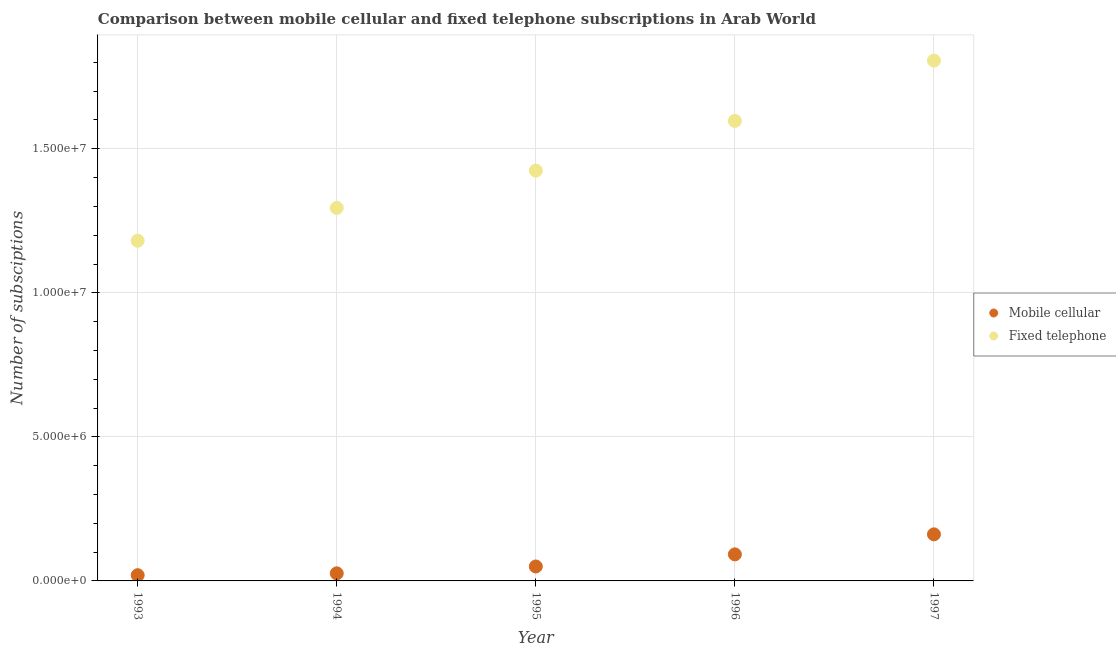What is the number of mobile cellular subscriptions in 1996?
Ensure brevity in your answer.  9.21e+05. Across all years, what is the maximum number of mobile cellular subscriptions?
Keep it short and to the point. 1.62e+06. Across all years, what is the minimum number of mobile cellular subscriptions?
Ensure brevity in your answer.  1.99e+05. In which year was the number of mobile cellular subscriptions maximum?
Give a very brief answer. 1997. What is the total number of fixed telephone subscriptions in the graph?
Provide a short and direct response. 7.30e+07. What is the difference between the number of fixed telephone subscriptions in 1993 and that in 1995?
Give a very brief answer. -2.43e+06. What is the difference between the number of fixed telephone subscriptions in 1994 and the number of mobile cellular subscriptions in 1996?
Offer a terse response. 1.20e+07. What is the average number of mobile cellular subscriptions per year?
Your answer should be very brief. 7.00e+05. In the year 1995, what is the difference between the number of fixed telephone subscriptions and number of mobile cellular subscriptions?
Ensure brevity in your answer.  1.37e+07. What is the ratio of the number of mobile cellular subscriptions in 1995 to that in 1997?
Provide a short and direct response. 0.31. Is the number of mobile cellular subscriptions in 1994 less than that in 1997?
Ensure brevity in your answer.  Yes. Is the difference between the number of mobile cellular subscriptions in 1994 and 1995 greater than the difference between the number of fixed telephone subscriptions in 1994 and 1995?
Keep it short and to the point. Yes. What is the difference between the highest and the second highest number of fixed telephone subscriptions?
Your response must be concise. 2.09e+06. What is the difference between the highest and the lowest number of fixed telephone subscriptions?
Ensure brevity in your answer.  6.25e+06. Does the number of fixed telephone subscriptions monotonically increase over the years?
Offer a very short reply. Yes. Is the number of mobile cellular subscriptions strictly less than the number of fixed telephone subscriptions over the years?
Your answer should be compact. Yes. Are the values on the major ticks of Y-axis written in scientific E-notation?
Make the answer very short. Yes. Where does the legend appear in the graph?
Keep it short and to the point. Center right. How many legend labels are there?
Ensure brevity in your answer.  2. How are the legend labels stacked?
Provide a succinct answer. Vertical. What is the title of the graph?
Your response must be concise. Comparison between mobile cellular and fixed telephone subscriptions in Arab World. Does "Residents" appear as one of the legend labels in the graph?
Provide a succinct answer. No. What is the label or title of the Y-axis?
Provide a succinct answer. Number of subsciptions. What is the Number of subsciptions of Mobile cellular in 1993?
Offer a terse response. 1.99e+05. What is the Number of subsciptions in Fixed telephone in 1993?
Keep it short and to the point. 1.18e+07. What is the Number of subsciptions in Mobile cellular in 1994?
Your answer should be compact. 2.63e+05. What is the Number of subsciptions in Fixed telephone in 1994?
Your answer should be compact. 1.29e+07. What is the Number of subsciptions in Mobile cellular in 1995?
Your answer should be compact. 5.02e+05. What is the Number of subsciptions of Fixed telephone in 1995?
Ensure brevity in your answer.  1.42e+07. What is the Number of subsciptions in Mobile cellular in 1996?
Provide a short and direct response. 9.21e+05. What is the Number of subsciptions of Fixed telephone in 1996?
Keep it short and to the point. 1.60e+07. What is the Number of subsciptions in Mobile cellular in 1997?
Your answer should be compact. 1.62e+06. What is the Number of subsciptions in Fixed telephone in 1997?
Your response must be concise. 1.81e+07. Across all years, what is the maximum Number of subsciptions of Mobile cellular?
Provide a short and direct response. 1.62e+06. Across all years, what is the maximum Number of subsciptions of Fixed telephone?
Ensure brevity in your answer.  1.81e+07. Across all years, what is the minimum Number of subsciptions in Mobile cellular?
Keep it short and to the point. 1.99e+05. Across all years, what is the minimum Number of subsciptions of Fixed telephone?
Ensure brevity in your answer.  1.18e+07. What is the total Number of subsciptions of Mobile cellular in the graph?
Provide a succinct answer. 3.50e+06. What is the total Number of subsciptions in Fixed telephone in the graph?
Your answer should be very brief. 7.30e+07. What is the difference between the Number of subsciptions of Mobile cellular in 1993 and that in 1994?
Keep it short and to the point. -6.41e+04. What is the difference between the Number of subsciptions of Fixed telephone in 1993 and that in 1994?
Give a very brief answer. -1.14e+06. What is the difference between the Number of subsciptions of Mobile cellular in 1993 and that in 1995?
Your answer should be compact. -3.02e+05. What is the difference between the Number of subsciptions in Fixed telephone in 1993 and that in 1995?
Your answer should be compact. -2.43e+06. What is the difference between the Number of subsciptions in Mobile cellular in 1993 and that in 1996?
Provide a short and direct response. -7.22e+05. What is the difference between the Number of subsciptions of Fixed telephone in 1993 and that in 1996?
Offer a terse response. -4.16e+06. What is the difference between the Number of subsciptions in Mobile cellular in 1993 and that in 1997?
Your response must be concise. -1.42e+06. What is the difference between the Number of subsciptions in Fixed telephone in 1993 and that in 1997?
Offer a terse response. -6.25e+06. What is the difference between the Number of subsciptions of Mobile cellular in 1994 and that in 1995?
Offer a very short reply. -2.38e+05. What is the difference between the Number of subsciptions in Fixed telephone in 1994 and that in 1995?
Your answer should be very brief. -1.29e+06. What is the difference between the Number of subsciptions in Mobile cellular in 1994 and that in 1996?
Give a very brief answer. -6.58e+05. What is the difference between the Number of subsciptions in Fixed telephone in 1994 and that in 1996?
Your answer should be compact. -3.02e+06. What is the difference between the Number of subsciptions in Mobile cellular in 1994 and that in 1997?
Keep it short and to the point. -1.35e+06. What is the difference between the Number of subsciptions in Fixed telephone in 1994 and that in 1997?
Your answer should be very brief. -5.11e+06. What is the difference between the Number of subsciptions of Mobile cellular in 1995 and that in 1996?
Keep it short and to the point. -4.20e+05. What is the difference between the Number of subsciptions of Fixed telephone in 1995 and that in 1996?
Your answer should be compact. -1.73e+06. What is the difference between the Number of subsciptions in Mobile cellular in 1995 and that in 1997?
Keep it short and to the point. -1.12e+06. What is the difference between the Number of subsciptions of Fixed telephone in 1995 and that in 1997?
Give a very brief answer. -3.82e+06. What is the difference between the Number of subsciptions in Mobile cellular in 1996 and that in 1997?
Offer a very short reply. -6.95e+05. What is the difference between the Number of subsciptions of Fixed telephone in 1996 and that in 1997?
Your response must be concise. -2.09e+06. What is the difference between the Number of subsciptions in Mobile cellular in 1993 and the Number of subsciptions in Fixed telephone in 1994?
Your answer should be compact. -1.27e+07. What is the difference between the Number of subsciptions in Mobile cellular in 1993 and the Number of subsciptions in Fixed telephone in 1995?
Your response must be concise. -1.40e+07. What is the difference between the Number of subsciptions in Mobile cellular in 1993 and the Number of subsciptions in Fixed telephone in 1996?
Ensure brevity in your answer.  -1.58e+07. What is the difference between the Number of subsciptions of Mobile cellular in 1993 and the Number of subsciptions of Fixed telephone in 1997?
Offer a very short reply. -1.79e+07. What is the difference between the Number of subsciptions in Mobile cellular in 1994 and the Number of subsciptions in Fixed telephone in 1995?
Ensure brevity in your answer.  -1.40e+07. What is the difference between the Number of subsciptions of Mobile cellular in 1994 and the Number of subsciptions of Fixed telephone in 1996?
Provide a succinct answer. -1.57e+07. What is the difference between the Number of subsciptions in Mobile cellular in 1994 and the Number of subsciptions in Fixed telephone in 1997?
Your response must be concise. -1.78e+07. What is the difference between the Number of subsciptions of Mobile cellular in 1995 and the Number of subsciptions of Fixed telephone in 1996?
Offer a terse response. -1.55e+07. What is the difference between the Number of subsciptions in Mobile cellular in 1995 and the Number of subsciptions in Fixed telephone in 1997?
Keep it short and to the point. -1.76e+07. What is the difference between the Number of subsciptions in Mobile cellular in 1996 and the Number of subsciptions in Fixed telephone in 1997?
Your answer should be very brief. -1.71e+07. What is the average Number of subsciptions of Mobile cellular per year?
Offer a very short reply. 7.00e+05. What is the average Number of subsciptions of Fixed telephone per year?
Offer a very short reply. 1.46e+07. In the year 1993, what is the difference between the Number of subsciptions in Mobile cellular and Number of subsciptions in Fixed telephone?
Your answer should be compact. -1.16e+07. In the year 1994, what is the difference between the Number of subsciptions of Mobile cellular and Number of subsciptions of Fixed telephone?
Give a very brief answer. -1.27e+07. In the year 1995, what is the difference between the Number of subsciptions of Mobile cellular and Number of subsciptions of Fixed telephone?
Ensure brevity in your answer.  -1.37e+07. In the year 1996, what is the difference between the Number of subsciptions in Mobile cellular and Number of subsciptions in Fixed telephone?
Your response must be concise. -1.50e+07. In the year 1997, what is the difference between the Number of subsciptions in Mobile cellular and Number of subsciptions in Fixed telephone?
Provide a succinct answer. -1.64e+07. What is the ratio of the Number of subsciptions in Mobile cellular in 1993 to that in 1994?
Offer a terse response. 0.76. What is the ratio of the Number of subsciptions in Fixed telephone in 1993 to that in 1994?
Offer a terse response. 0.91. What is the ratio of the Number of subsciptions in Mobile cellular in 1993 to that in 1995?
Offer a very short reply. 0.4. What is the ratio of the Number of subsciptions of Fixed telephone in 1993 to that in 1995?
Provide a succinct answer. 0.83. What is the ratio of the Number of subsciptions of Mobile cellular in 1993 to that in 1996?
Provide a short and direct response. 0.22. What is the ratio of the Number of subsciptions in Fixed telephone in 1993 to that in 1996?
Offer a terse response. 0.74. What is the ratio of the Number of subsciptions in Mobile cellular in 1993 to that in 1997?
Your answer should be very brief. 0.12. What is the ratio of the Number of subsciptions in Fixed telephone in 1993 to that in 1997?
Provide a short and direct response. 0.65. What is the ratio of the Number of subsciptions of Mobile cellular in 1994 to that in 1995?
Your answer should be very brief. 0.53. What is the ratio of the Number of subsciptions of Mobile cellular in 1994 to that in 1996?
Provide a succinct answer. 0.29. What is the ratio of the Number of subsciptions of Fixed telephone in 1994 to that in 1996?
Your answer should be compact. 0.81. What is the ratio of the Number of subsciptions in Mobile cellular in 1994 to that in 1997?
Provide a short and direct response. 0.16. What is the ratio of the Number of subsciptions of Fixed telephone in 1994 to that in 1997?
Your answer should be compact. 0.72. What is the ratio of the Number of subsciptions in Mobile cellular in 1995 to that in 1996?
Provide a short and direct response. 0.54. What is the ratio of the Number of subsciptions of Fixed telephone in 1995 to that in 1996?
Your answer should be very brief. 0.89. What is the ratio of the Number of subsciptions in Mobile cellular in 1995 to that in 1997?
Give a very brief answer. 0.31. What is the ratio of the Number of subsciptions in Fixed telephone in 1995 to that in 1997?
Provide a succinct answer. 0.79. What is the ratio of the Number of subsciptions of Mobile cellular in 1996 to that in 1997?
Provide a succinct answer. 0.57. What is the ratio of the Number of subsciptions of Fixed telephone in 1996 to that in 1997?
Ensure brevity in your answer.  0.88. What is the difference between the highest and the second highest Number of subsciptions of Mobile cellular?
Provide a short and direct response. 6.95e+05. What is the difference between the highest and the second highest Number of subsciptions of Fixed telephone?
Make the answer very short. 2.09e+06. What is the difference between the highest and the lowest Number of subsciptions in Mobile cellular?
Keep it short and to the point. 1.42e+06. What is the difference between the highest and the lowest Number of subsciptions of Fixed telephone?
Ensure brevity in your answer.  6.25e+06. 